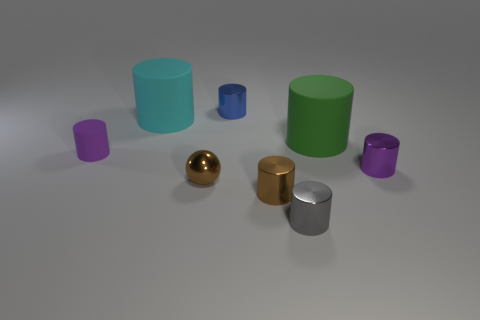Based on their appearance, what material do you think these objects are made of? Based on the visual characteristics, the tiny brown cylinder and the gold sphere seem to be made of some kind of metal due to their reflective qualities. The matte cylinders, colored purple, cyan, and green, might be composed of a plastic or painted ceramic material, suggested by their non-reflective surfaces. 